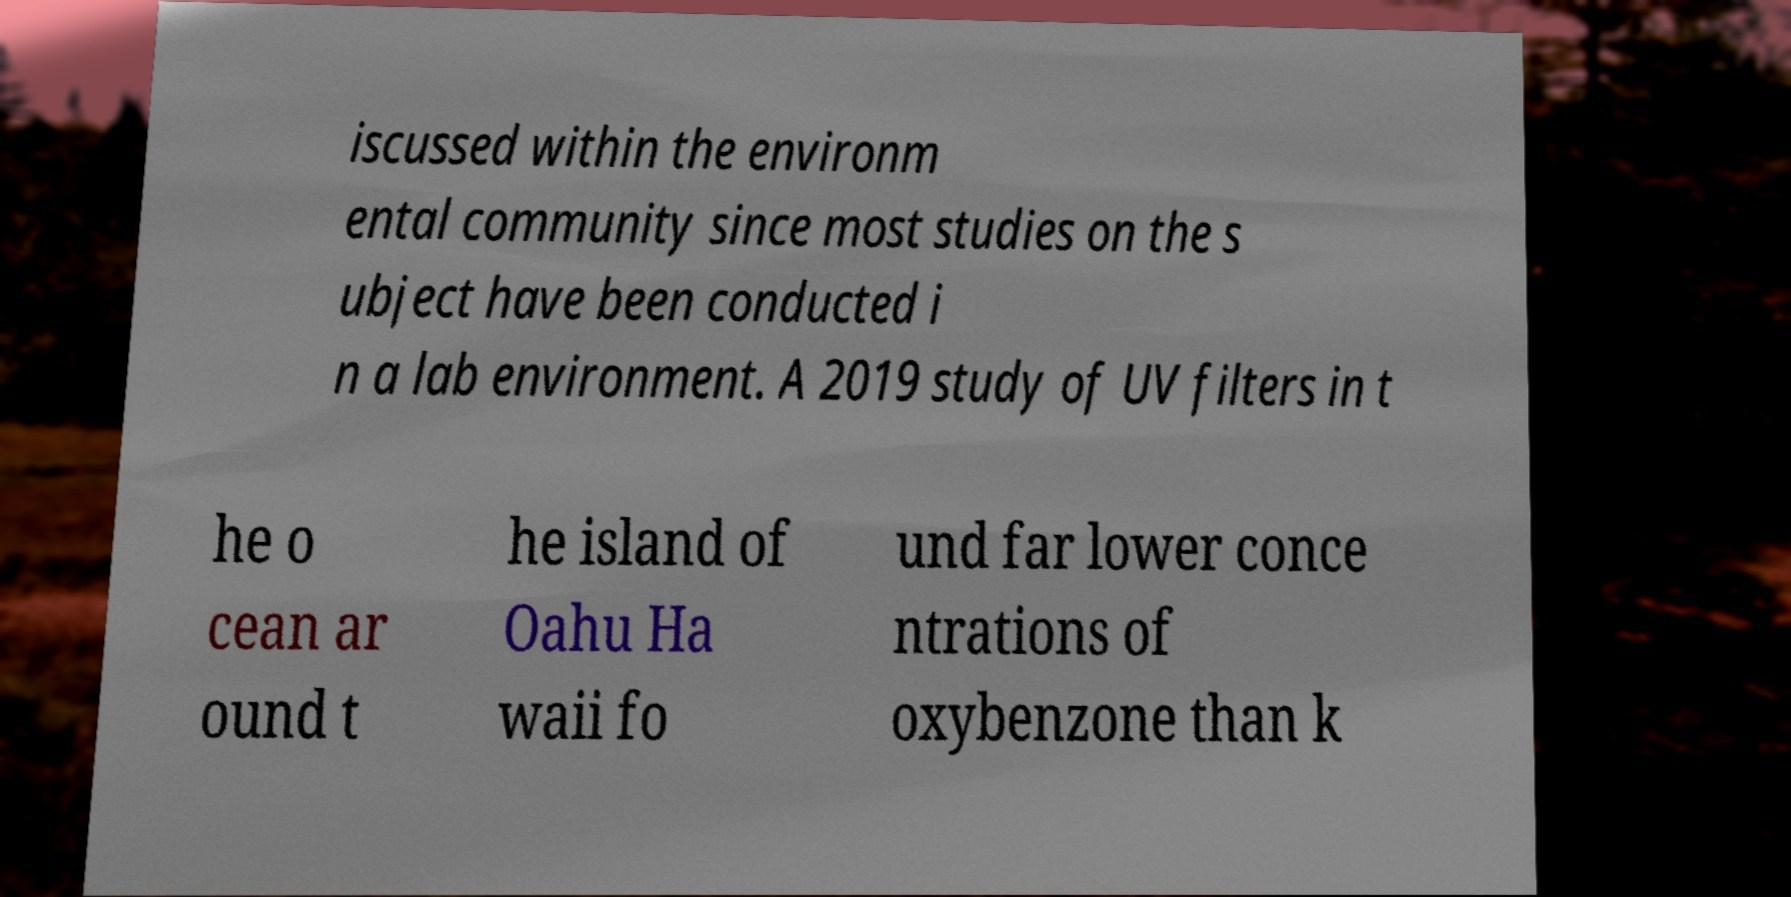For documentation purposes, I need the text within this image transcribed. Could you provide that? iscussed within the environm ental community since most studies on the s ubject have been conducted i n a lab environment. A 2019 study of UV filters in t he o cean ar ound t he island of Oahu Ha waii fo und far lower conce ntrations of oxybenzone than k 